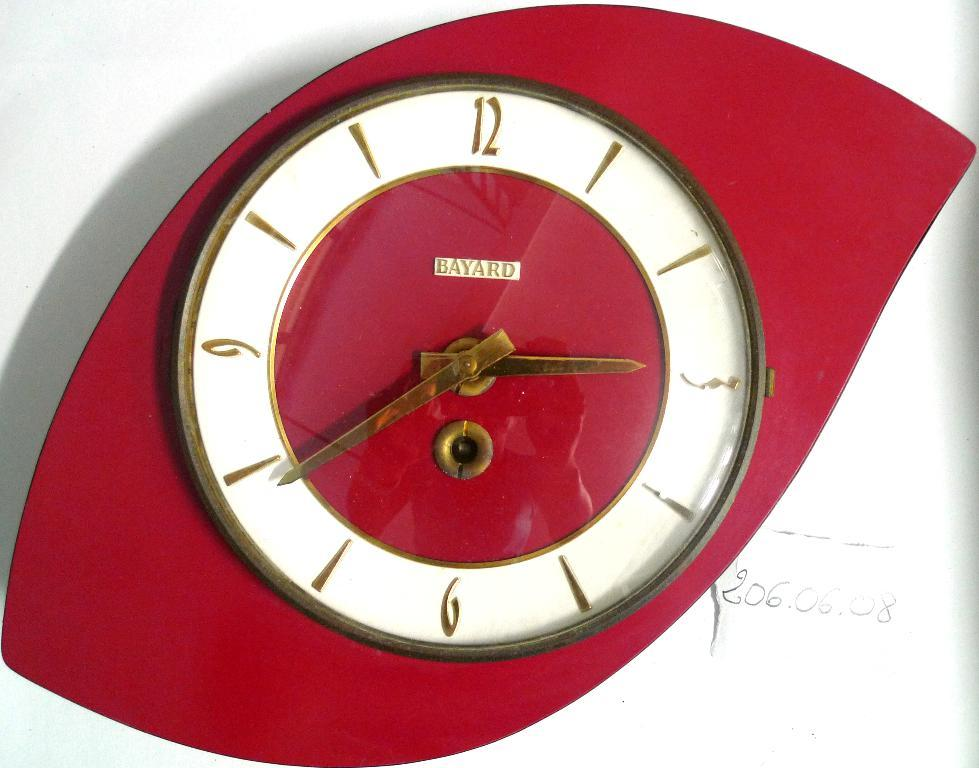<image>
Present a compact description of the photo's key features. A red clock from Bayard hangs on a white wall. 